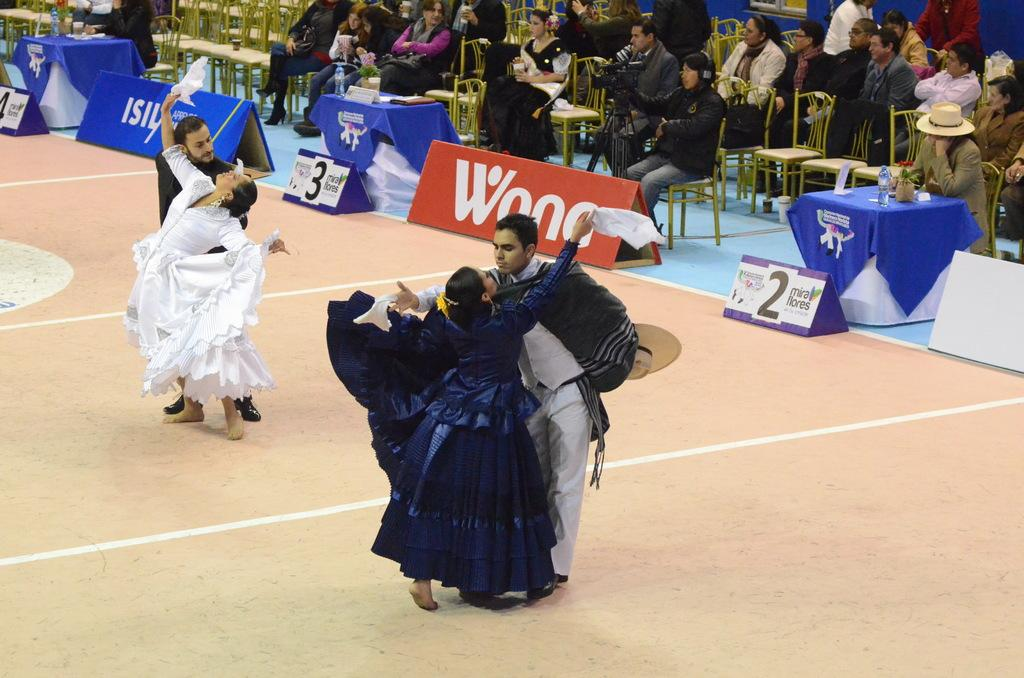What are the people in the image doing? There are persons sitting on chairs and performing on the floor in the image. What type of objects can be seen in the image besides the people? There are advertisement boards, benches, disposal bottles, and flower vases in the image. Can you describe the seating arrangements in the image? There are chairs and benches present in the image. What might be used for holding flowers in the image? There are flower vases in the image for holding flowers. How many horses are visible in the image? There are no horses present in the image. What type of seed can be seen growing in the image? There is no seed growing in the image; it does not contain any plants or vegetation. 